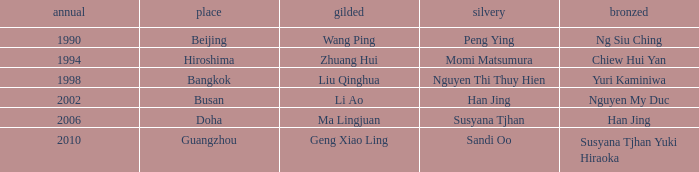What Silver has the Location of Guangzhou? Sandi Oo. 